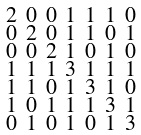Convert formula to latex. <formula><loc_0><loc_0><loc_500><loc_500>\begin{smallmatrix} 2 & 0 & 0 & 1 & 1 & 1 & 0 \\ 0 & 2 & 0 & 1 & 1 & 0 & 1 \\ 0 & 0 & 2 & 1 & 0 & 1 & 0 \\ 1 & 1 & 1 & 3 & 1 & 1 & 1 \\ 1 & 1 & 0 & 1 & 3 & 1 & 0 \\ 1 & 0 & 1 & 1 & 1 & 3 & 1 \\ 0 & 1 & 0 & 1 & 0 & 1 & 3 \end{smallmatrix}</formula> 